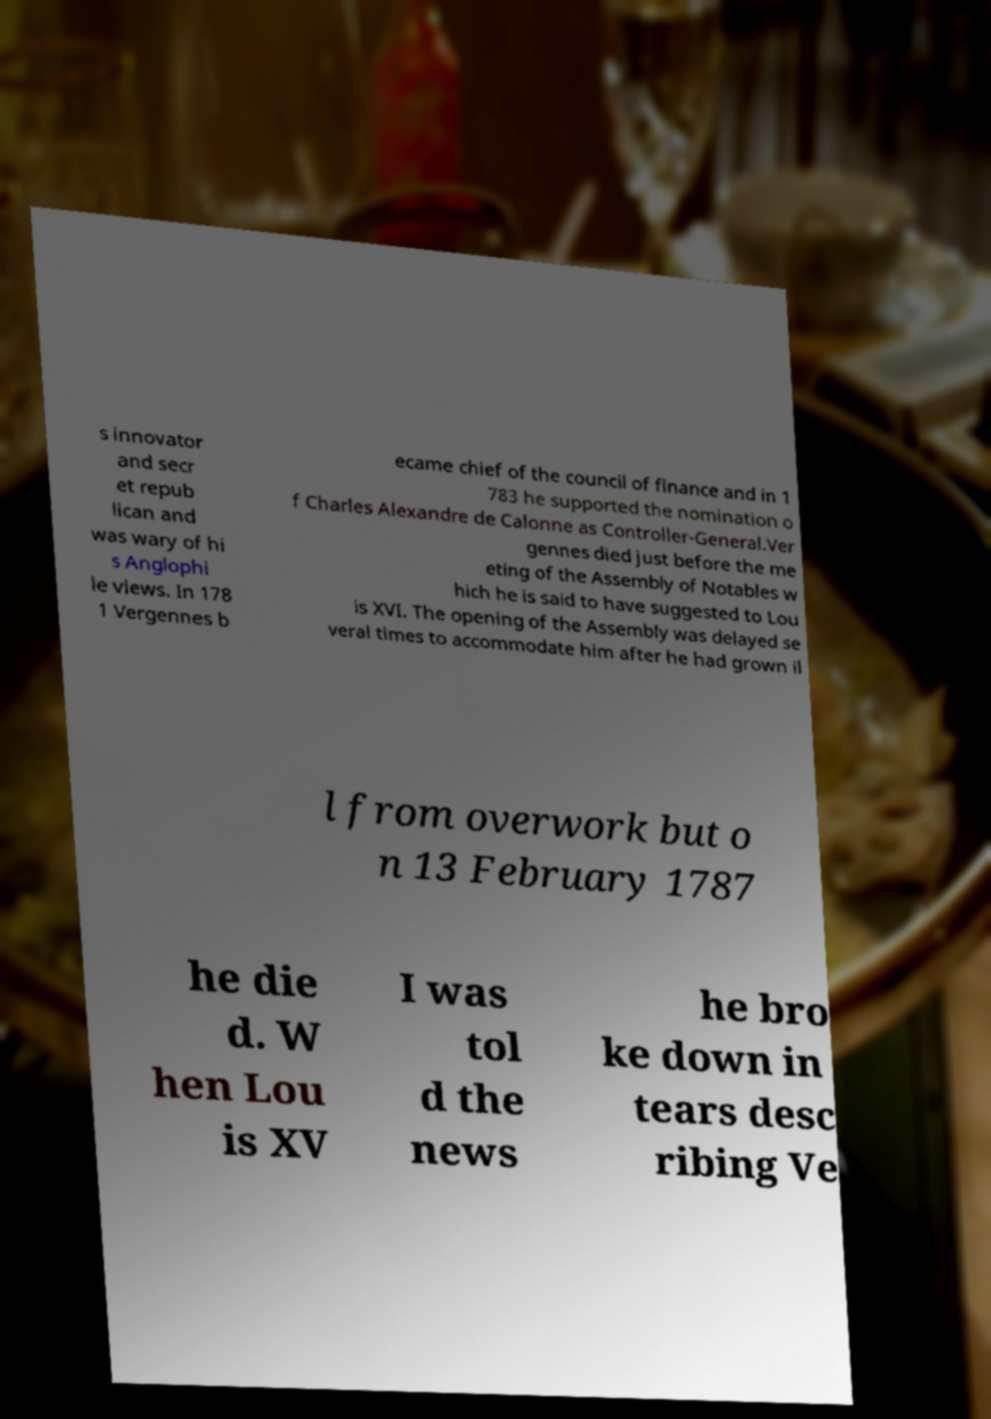Can you accurately transcribe the text from the provided image for me? s innovator and secr et repub lican and was wary of hi s Anglophi le views. In 178 1 Vergennes b ecame chief of the council of finance and in 1 783 he supported the nomination o f Charles Alexandre de Calonne as Controller-General.Ver gennes died just before the me eting of the Assembly of Notables w hich he is said to have suggested to Lou is XVI. The opening of the Assembly was delayed se veral times to accommodate him after he had grown il l from overwork but o n 13 February 1787 he die d. W hen Lou is XV I was tol d the news he bro ke down in tears desc ribing Ve 